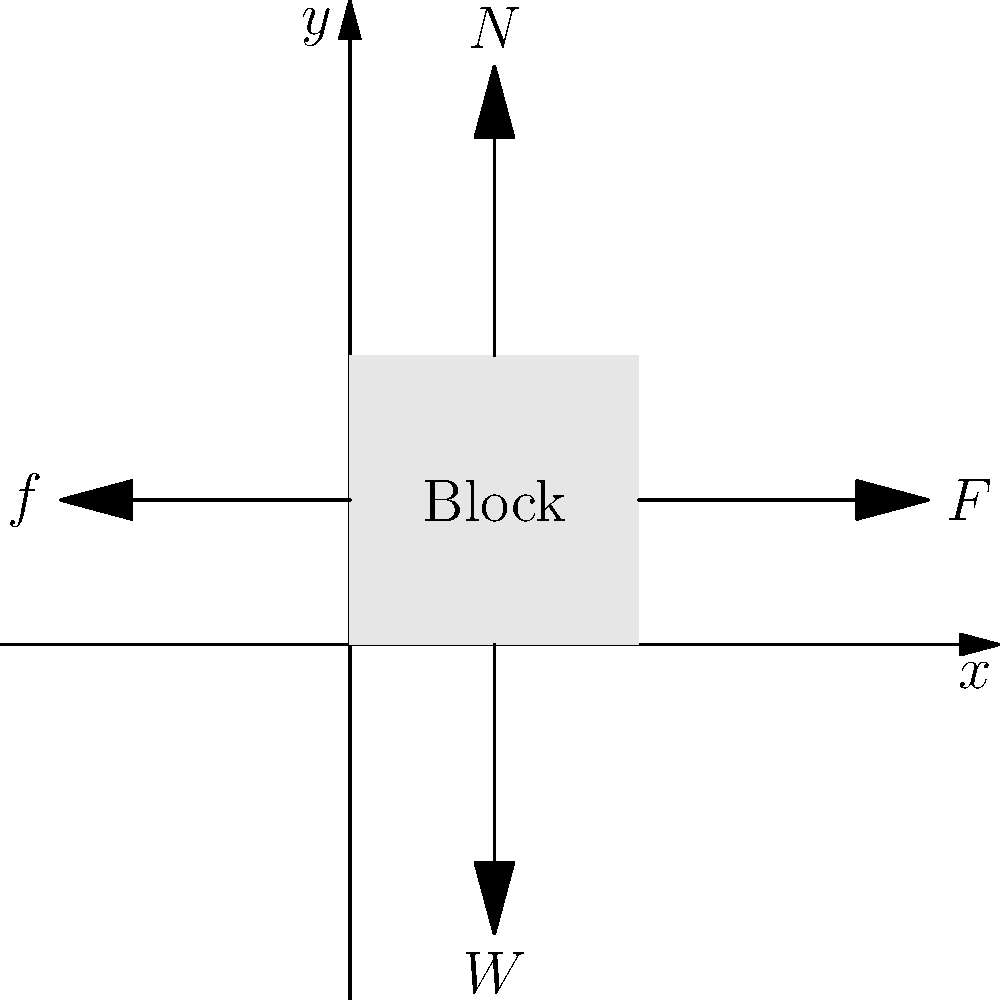A block is at rest on a horizontal surface. Four forces act on the block: normal force ($N$), weight ($W$), applied force ($F$), and friction ($f$). If the block remains stationary, which of Newton's laws of motion is best illustrated by this scenario, and what relationship between the forces can be deduced? To answer this question, let's analyze the scenario step-by-step using Newton's laws of motion:

1. Newton's First Law: An object at rest stays at rest unless acted upon by an unbalanced force.

2. Newton's Second Law: The acceleration of an object is directly proportional to the net force acting on it and inversely proportional to its mass.

3. Newton's Third Law: For every action, there is an equal and opposite reaction.

In this scenario:
a) The block is at rest, which means it has zero acceleration.
b) Multiple forces are acting on the block, yet it remains stationary.

These observations point to Newton's First Law being the best illustrated here. The block remains at rest because the net force acting on it is zero.

To deduce the relationship between forces:

1. Vertical forces:
   $N - W = 0$ (Normal force balances the weight)

2. Horizontal forces:
   $F - f = 0$ (Applied force is balanced by friction)

Therefore, we can conclude that the forces are in equilibrium, with opposing forces being equal in magnitude but opposite in direction.

This scenario demonstrates how a young aspiring lawyer might approach analyzing a physical situation: by systematically applying known principles (laws) to deduce relationships and draw conclusions, which is analogous to applying legal precedents and statutes to analyze legal cases.
Answer: Newton's First Law; forces are in equilibrium ($N = W$ and $F = f$). 